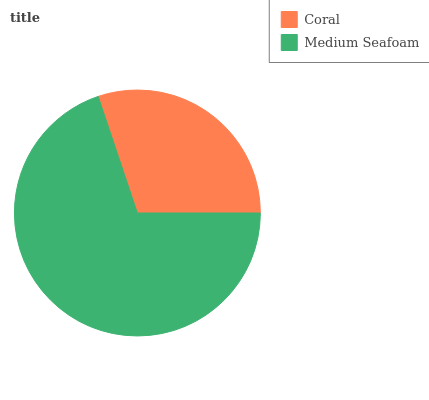Is Coral the minimum?
Answer yes or no. Yes. Is Medium Seafoam the maximum?
Answer yes or no. Yes. Is Medium Seafoam the minimum?
Answer yes or no. No. Is Medium Seafoam greater than Coral?
Answer yes or no. Yes. Is Coral less than Medium Seafoam?
Answer yes or no. Yes. Is Coral greater than Medium Seafoam?
Answer yes or no. No. Is Medium Seafoam less than Coral?
Answer yes or no. No. Is Medium Seafoam the high median?
Answer yes or no. Yes. Is Coral the low median?
Answer yes or no. Yes. Is Coral the high median?
Answer yes or no. No. Is Medium Seafoam the low median?
Answer yes or no. No. 